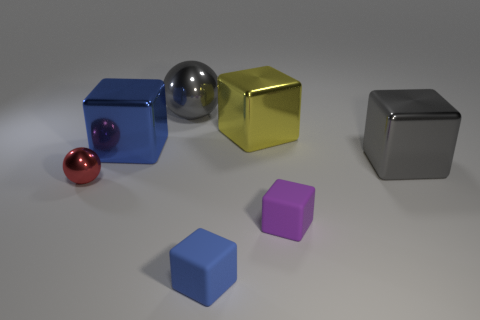What number of metallic objects are either tiny blue cubes or tiny purple things?
Offer a terse response. 0. Is the number of big metallic spheres that are in front of the tiny blue rubber block less than the number of tiny spheres left of the purple rubber cube?
Keep it short and to the point. Yes. Are there any blocks on the right side of the cube on the left side of the blue cube that is in front of the small red sphere?
Give a very brief answer. Yes. What material is the big block that is the same color as the big metallic sphere?
Your response must be concise. Metal. There is a big gray object that is to the right of the blue matte object; is it the same shape as the matte thing behind the blue matte block?
Your response must be concise. Yes. There is a blue object that is the same size as the purple thing; what is its material?
Offer a very short reply. Rubber. Does the blue cube right of the gray metallic sphere have the same material as the object to the right of the tiny purple thing?
Provide a succinct answer. No. There is a red object that is the same size as the blue matte cube; what is its shape?
Make the answer very short. Sphere. How many other objects are there of the same color as the large ball?
Provide a short and direct response. 1. There is a big metallic object that is behind the large yellow metal cube; what color is it?
Your answer should be very brief. Gray. 